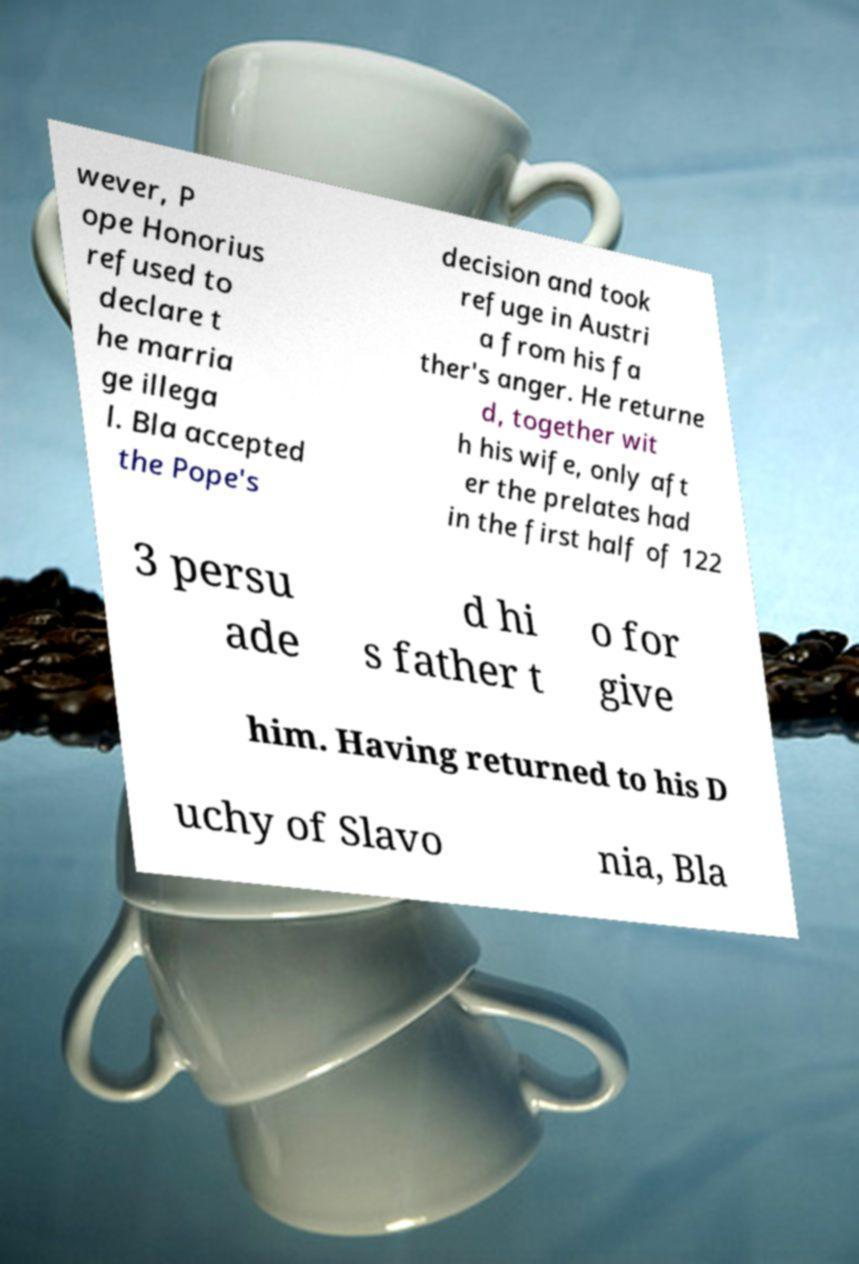Can you accurately transcribe the text from the provided image for me? wever, P ope Honorius refused to declare t he marria ge illega l. Bla accepted the Pope's decision and took refuge in Austri a from his fa ther's anger. He returne d, together wit h his wife, only aft er the prelates had in the first half of 122 3 persu ade d hi s father t o for give him. Having returned to his D uchy of Slavo nia, Bla 